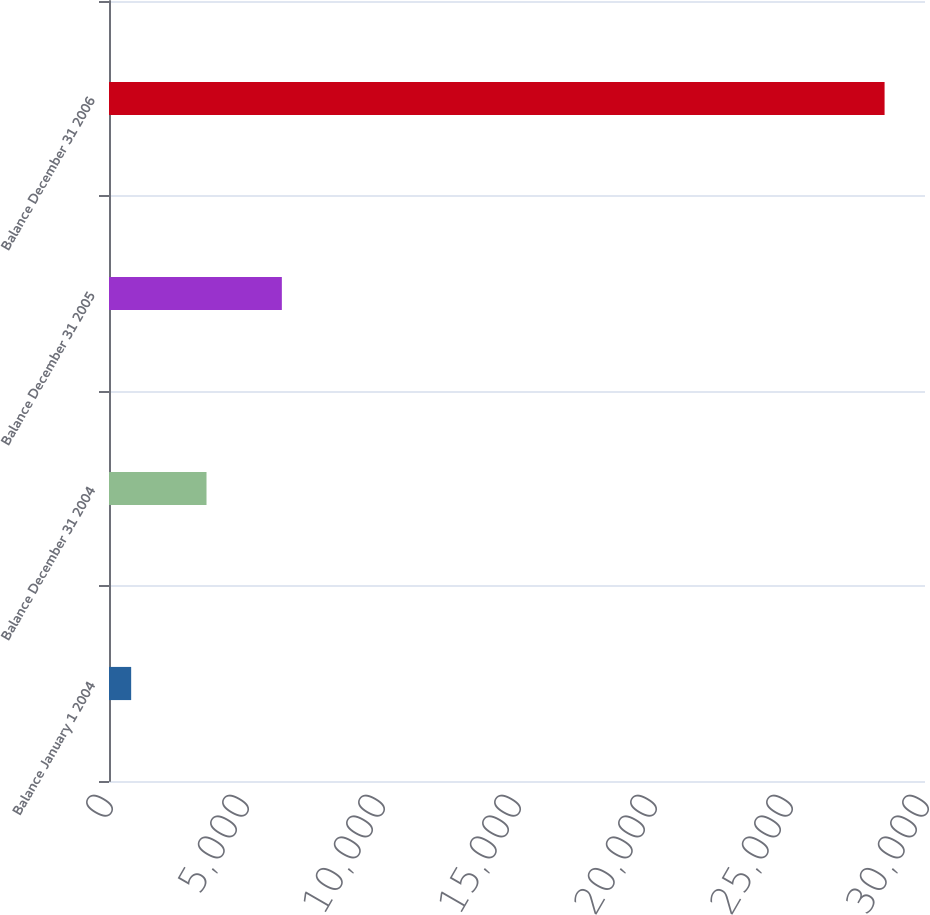Convert chart. <chart><loc_0><loc_0><loc_500><loc_500><bar_chart><fcel>Balance January 1 2004<fcel>Balance December 31 2004<fcel>Balance December 31 2005<fcel>Balance December 31 2006<nl><fcel>815<fcel>3584.9<fcel>6354.8<fcel>28514<nl></chart> 